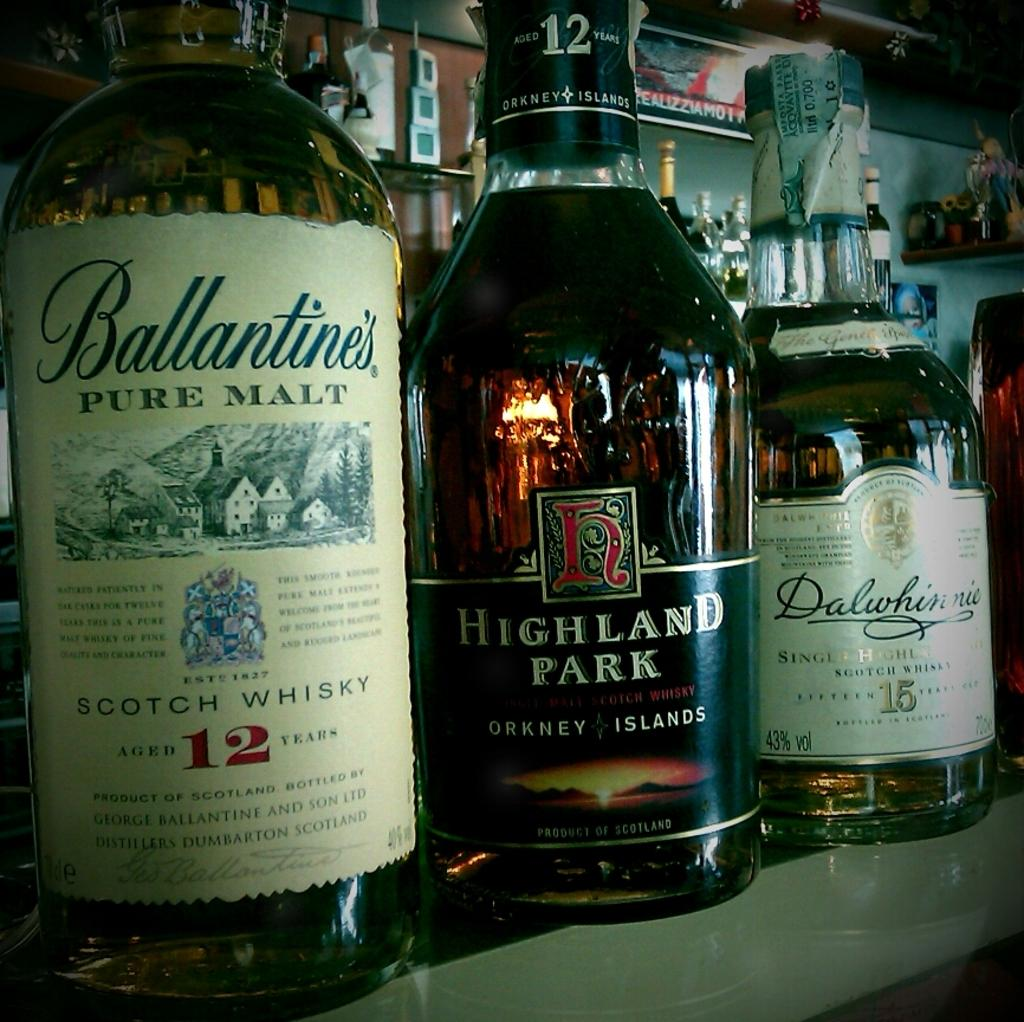<image>
Provide a brief description of the given image. Three liquor bottles on a table one which reads Ballantine's Pure Malt Scotch Whisky. 